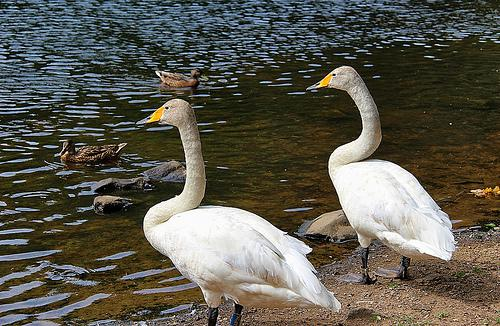Question: how are the geese?
Choices:
A. In V formation overhead.
B. Hanging in the shop window.
C. In the pond swimming.
D. Motionless.
Answer with the letter. Answer: D Question: where was this photo taken?
Choices:
A. On a shoreline.
B. In the city.
C. In bedroom.
D. Bathroom.
Answer with the letter. Answer: A Question: what are these?
Choices:
A. Hot dogs.
B. Geese.
C. Fans.
D. Rutabagas.
Answer with the letter. Answer: B 